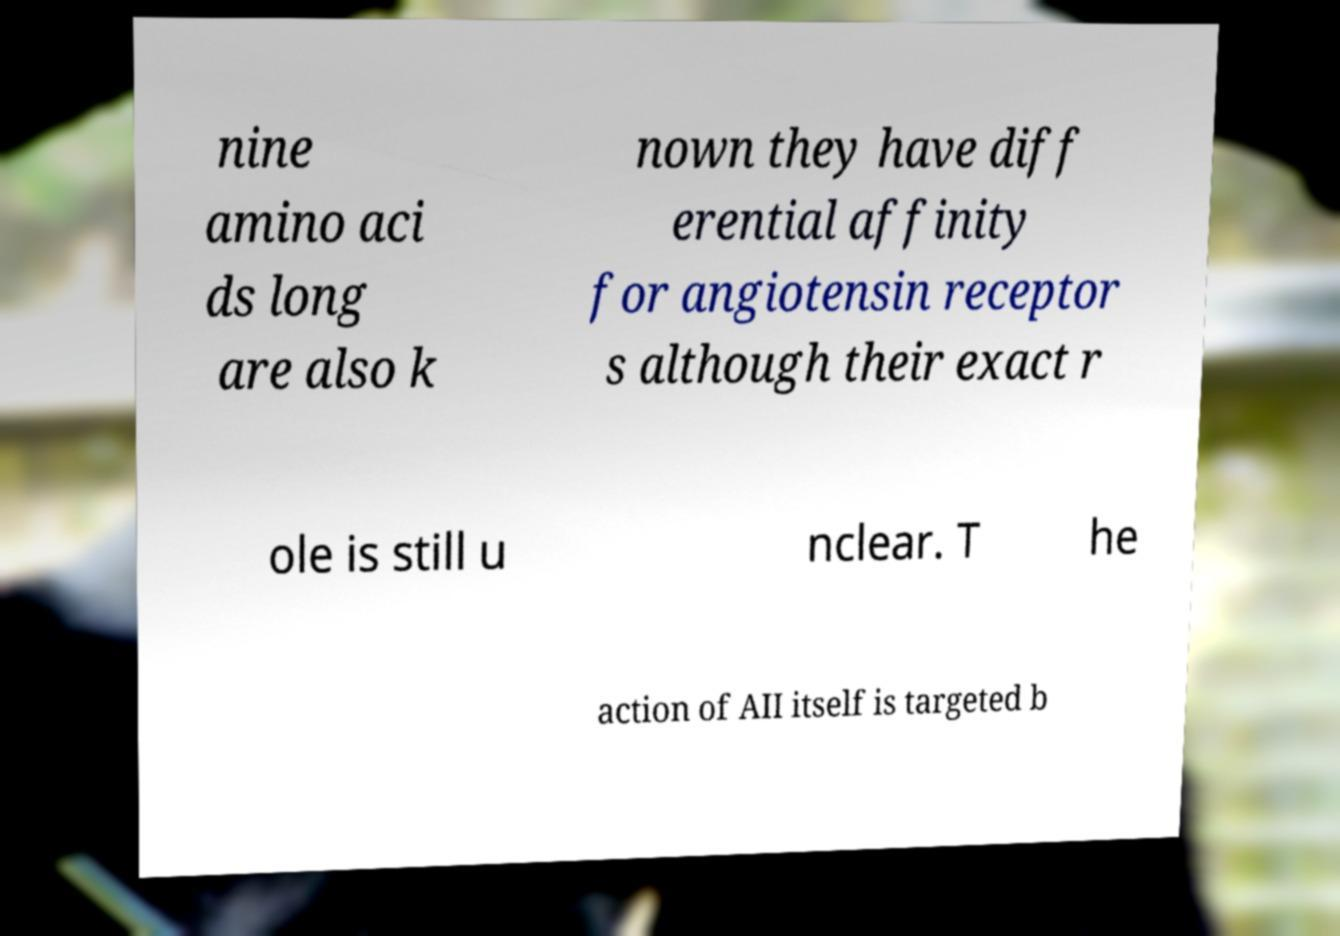Could you assist in decoding the text presented in this image and type it out clearly? nine amino aci ds long are also k nown they have diff erential affinity for angiotensin receptor s although their exact r ole is still u nclear. T he action of AII itself is targeted b 